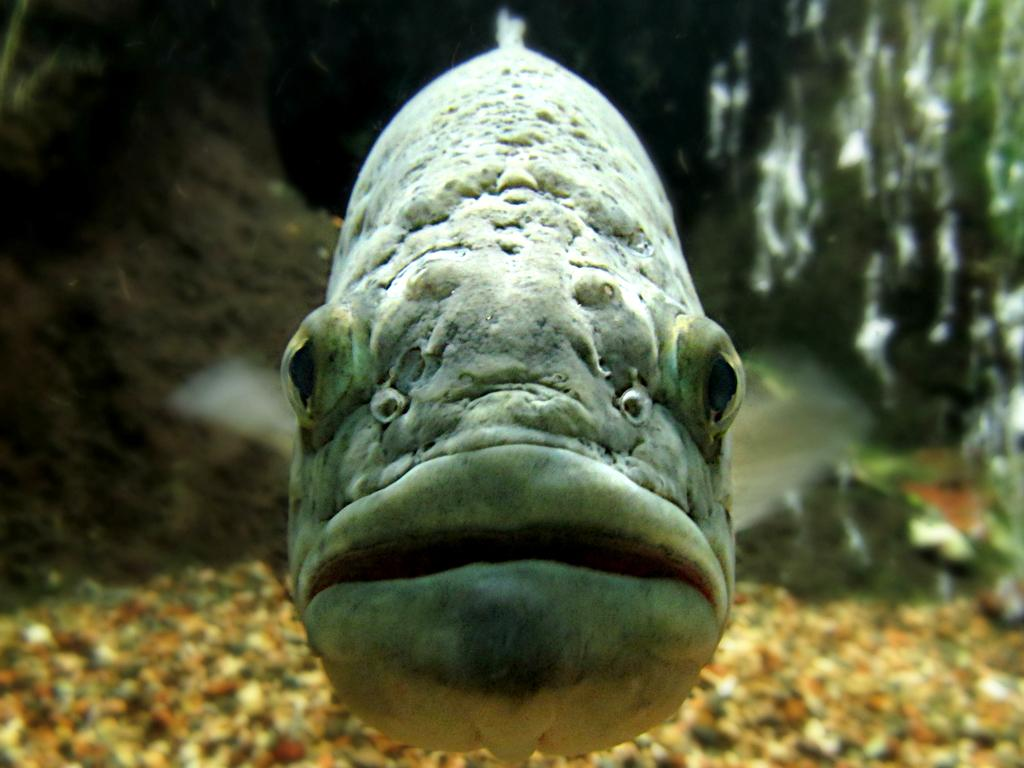What type of animal is in the image? There is a fish in the image. What else can be seen in the image besides the fish? There are stones in the image. What is visible in the background of the image? There are objects in the background of the image. Where is the faucet located in the image? There is no faucet present in the image. What type of slope can be seen in the image? There is no slope present in the image. 